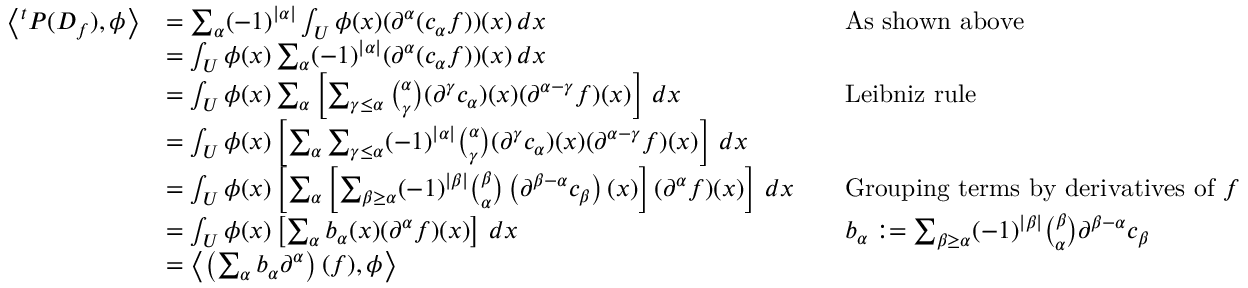Convert formula to latex. <formula><loc_0><loc_0><loc_500><loc_500>{ \begin{array} { r l r l } { \left \langle ^ { t } P ( D _ { f } ) , \phi \right \rangle } & { = \sum _ { \alpha } ( - 1 ) ^ { | \alpha | } \int _ { U } \phi ( x ) ( \partial ^ { \alpha } ( c _ { \alpha } f ) ) ( x ) \, d x } & & { A s s h o w n a b o v e } \\ & { = \int _ { U } \phi ( x ) \sum _ { \alpha } ( - 1 ) ^ { | \alpha | } ( \partial ^ { \alpha } ( c _ { \alpha } f ) ) ( x ) \, d x } \\ & { = \int _ { U } \phi ( x ) \sum _ { \alpha } \left [ \sum _ { \gamma \leq \alpha } { \binom { \alpha } { \gamma } } ( \partial ^ { \gamma } c _ { \alpha } ) ( x ) ( \partial ^ { \alpha - \gamma } f ) ( x ) \right ] \, d x } & & { L e i b n i z r u l e } \\ & { = \int _ { U } \phi ( x ) \left [ \sum _ { \alpha } \sum _ { \gamma \leq \alpha } ( - 1 ) ^ { | \alpha | } { \binom { \alpha } { \gamma } } ( \partial ^ { \gamma } c _ { \alpha } ) ( x ) ( \partial ^ { \alpha - \gamma } f ) ( x ) \right ] \, d x } \\ & { = \int _ { U } \phi ( x ) \left [ \sum _ { \alpha } \left [ \sum _ { \beta \geq \alpha } ( - 1 ) ^ { | \beta | } { \binom { \beta } { \alpha } } \left ( \partial ^ { \beta - \alpha } c _ { \beta } \right ) ( x ) \right ] ( \partial ^ { \alpha } f ) ( x ) \right ] \, d x } & & { { G r o u p i n g t e r m s b y d e r i v a t i v e s o f } f } \\ & { = \int _ { U } \phi ( x ) \left [ \sum _ { \alpha } b _ { \alpha } ( x ) ( \partial ^ { \alpha } f ) ( x ) \right ] \, d x } & & { b _ { \alpha } \colon = \sum _ { \beta \geq \alpha } ( - 1 ) ^ { | \beta | } { \binom { \beta } { \alpha } } \partial ^ { \beta - \alpha } c _ { \beta } } \\ & { = \left \langle \left ( \sum _ { \alpha } b _ { \alpha } \partial ^ { \alpha } \right ) ( f ) , \phi \right \rangle } \end{array} }</formula> 